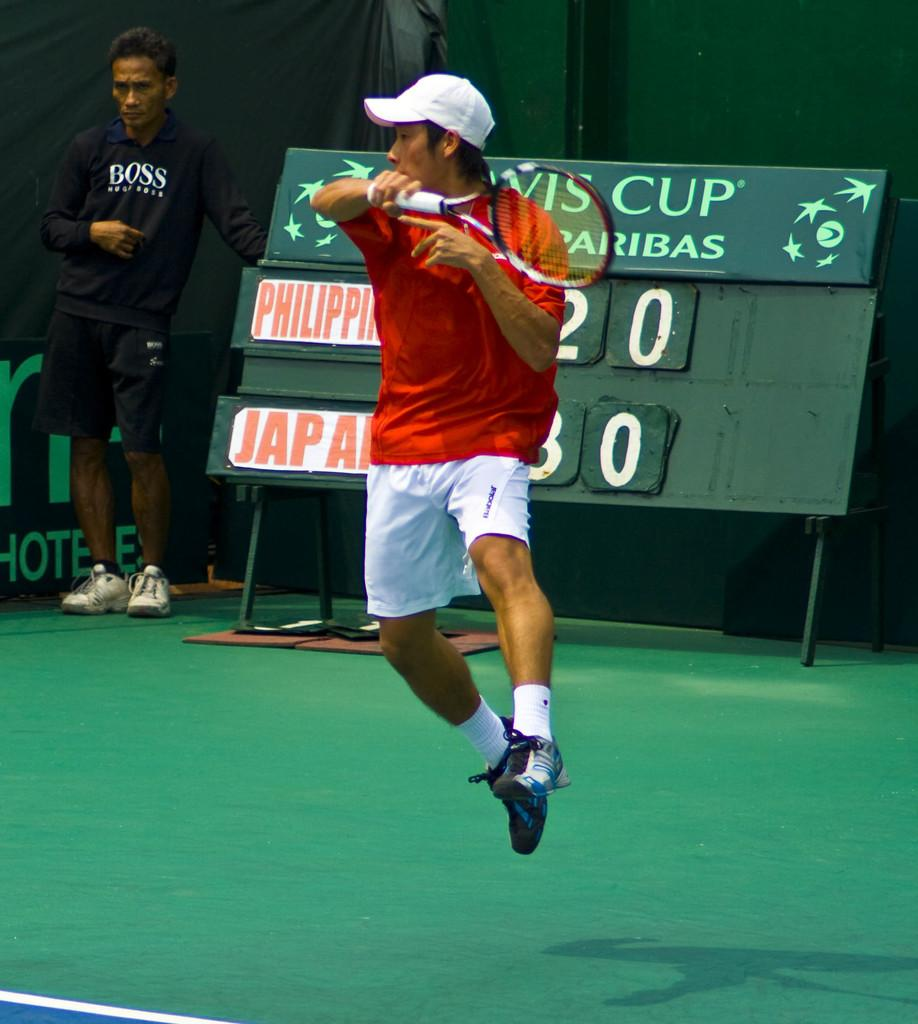What is the man in the image doing? The man is playing tennis in the image. What equipment is the man using to play tennis? The man is using a tennis racket. Can you describe the other person in the image? There is another man standing in the background of the image. How many children are playing with the orange in the image? There are no children or oranges present in the image. 